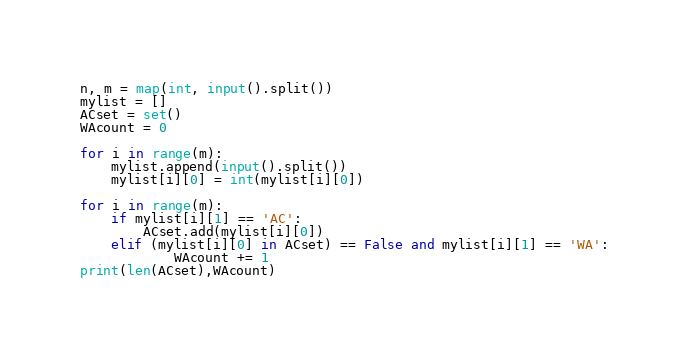<code> <loc_0><loc_0><loc_500><loc_500><_Python_>n, m = map(int, input().split())
mylist = []
ACset = set()
WAcount = 0

for i in range(m):
    mylist.append(input().split())
    mylist[i][0] = int(mylist[i][0])

for i in range(m):
    if mylist[i][1] == 'AC':
        ACset.add(mylist[i][0])
    elif (mylist[i][0] in ACset) == False and mylist[i][1] == 'WA':
            WAcount += 1
print(len(ACset),WAcount)</code> 